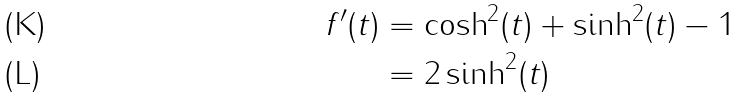<formula> <loc_0><loc_0><loc_500><loc_500>f ^ { \prime } ( t ) & = \cosh ^ { 2 } ( t ) + \sinh ^ { 2 } ( t ) - 1 \\ & = 2 \sinh ^ { 2 } ( t )</formula> 